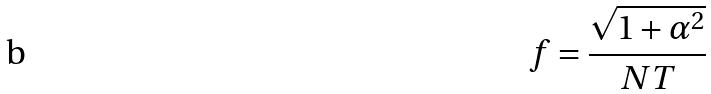Convert formula to latex. <formula><loc_0><loc_0><loc_500><loc_500>f = \frac { \sqrt { 1 + \alpha ^ { 2 } } } { N T }</formula> 